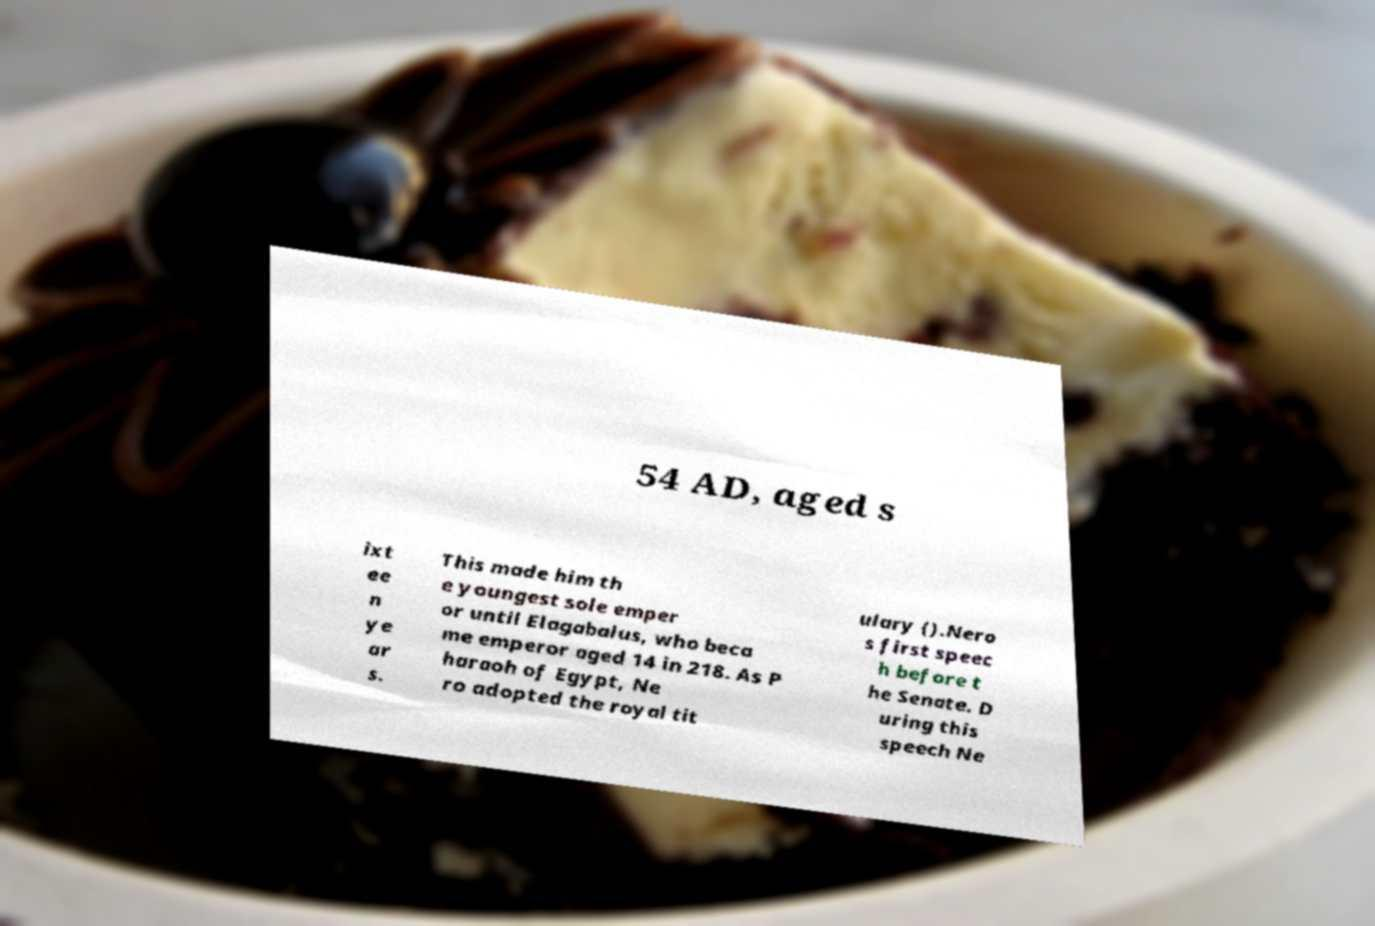For documentation purposes, I need the text within this image transcribed. Could you provide that? 54 AD, aged s ixt ee n ye ar s. This made him th e youngest sole emper or until Elagabalus, who beca me emperor aged 14 in 218. As P haraoh of Egypt, Ne ro adopted the royal tit ulary ().Nero s first speec h before t he Senate. D uring this speech Ne 